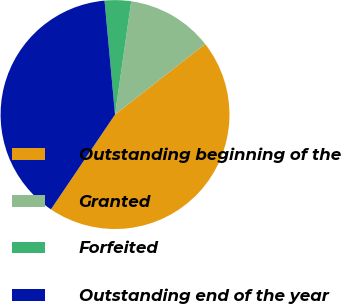<chart> <loc_0><loc_0><loc_500><loc_500><pie_chart><fcel>Outstanding beginning of the<fcel>Granted<fcel>Forfeited<fcel>Outstanding end of the year<nl><fcel>45.04%<fcel>12.17%<fcel>3.72%<fcel>39.08%<nl></chart> 